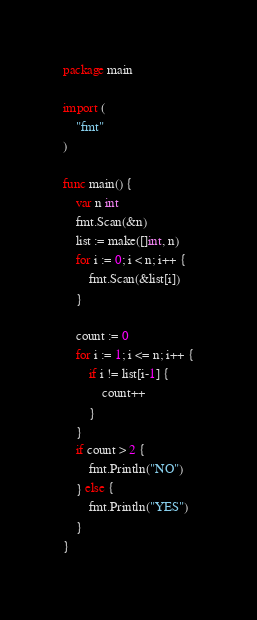Convert code to text. <code><loc_0><loc_0><loc_500><loc_500><_Go_>package main

import (
	"fmt"
)

func main() {
	var n int
	fmt.Scan(&n)
	list := make([]int, n)
	for i := 0; i < n; i++ {
		fmt.Scan(&list[i])
	}

	count := 0
	for i := 1; i <= n; i++ {
		if i != list[i-1] {
			count++
		}
	}
	if count > 2 {
		fmt.Println("NO")
	} else {
		fmt.Println("YES")
	}
}
</code> 